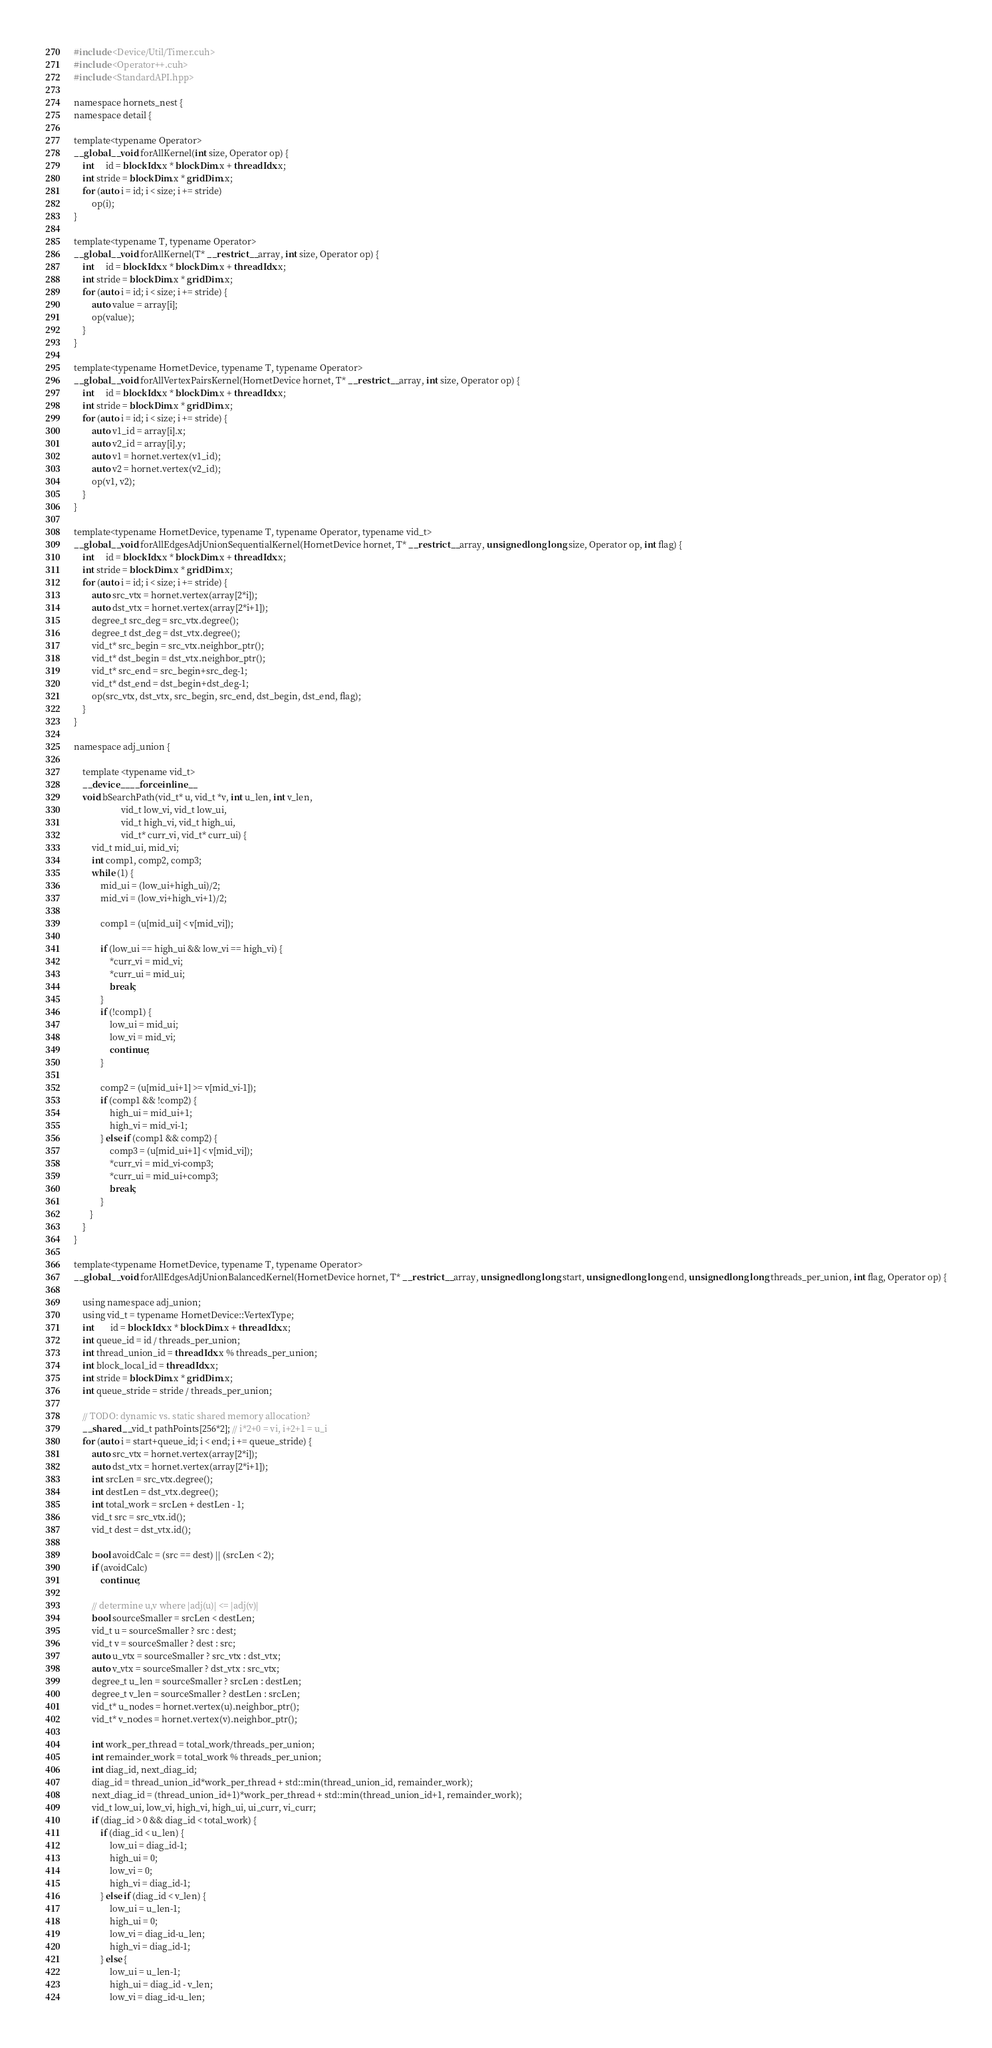Convert code to text. <code><loc_0><loc_0><loc_500><loc_500><_Cuda_>#include <Device/Util/Timer.cuh>
#include <Operator++.cuh>
#include <StandardAPI.hpp>

namespace hornets_nest {
namespace detail {

template<typename Operator>
__global__ void forAllKernel(int size, Operator op) {
    int     id = blockIdx.x * blockDim.x + threadIdx.x;
    int stride = blockDim.x * gridDim.x;
    for (auto i = id; i < size; i += stride)
        op(i);
}

template<typename T, typename Operator>
__global__ void forAllKernel(T* __restrict__ array, int size, Operator op) {
    int     id = blockIdx.x * blockDim.x + threadIdx.x;
    int stride = blockDim.x * gridDim.x;
    for (auto i = id; i < size; i += stride) {
        auto value = array[i];
        op(value);
    }
}

template<typename HornetDevice, typename T, typename Operator>
__global__ void forAllVertexPairsKernel(HornetDevice hornet, T* __restrict__ array, int size, Operator op) {
    int     id = blockIdx.x * blockDim.x + threadIdx.x;
    int stride = blockDim.x * gridDim.x;
    for (auto i = id; i < size; i += stride) {
        auto v1_id = array[i].x;
        auto v2_id = array[i].y;
        auto v1 = hornet.vertex(v1_id);
        auto v2 = hornet.vertex(v2_id);
        op(v1, v2);
    }
}

template<typename HornetDevice, typename T, typename Operator, typename vid_t>
__global__ void forAllEdgesAdjUnionSequentialKernel(HornetDevice hornet, T* __restrict__ array, unsigned long long size, Operator op, int flag) {
    int     id = blockIdx.x * blockDim.x + threadIdx.x;
    int stride = blockDim.x * gridDim.x;
    for (auto i = id; i < size; i += stride) {
        auto src_vtx = hornet.vertex(array[2*i]);
        auto dst_vtx = hornet.vertex(array[2*i+1]);
        degree_t src_deg = src_vtx.degree();
        degree_t dst_deg = dst_vtx.degree();
        vid_t* src_begin = src_vtx.neighbor_ptr();
        vid_t* dst_begin = dst_vtx.neighbor_ptr();
        vid_t* src_end = src_begin+src_deg-1;
        vid_t* dst_end = dst_begin+dst_deg-1;
        op(src_vtx, dst_vtx, src_begin, src_end, dst_begin, dst_end, flag);
    }
}

namespace adj_union {
    
    template <typename vid_t>
    __device__ __forceinline__
    void bSearchPath(vid_t* u, vid_t *v, int u_len, int v_len, 
                     vid_t low_vi, vid_t low_ui, 
                     vid_t high_vi, vid_t high_ui, 
                     vid_t* curr_vi, vid_t* curr_ui) {
        vid_t mid_ui, mid_vi;
        int comp1, comp2, comp3;
        while (1) {
            mid_ui = (low_ui+high_ui)/2;
            mid_vi = (low_vi+high_vi+1)/2;

            comp1 = (u[mid_ui] < v[mid_vi]);
            
            if (low_ui == high_ui && low_vi == high_vi) {
                *curr_vi = mid_vi;
                *curr_ui = mid_ui;
                break;
            }
            if (!comp1) {
                low_ui = mid_ui;
                low_vi = mid_vi;
                continue;
            }

            comp2 = (u[mid_ui+1] >= v[mid_vi-1]);
            if (comp1 && !comp2) {
                high_ui = mid_ui+1;
                high_vi = mid_vi-1;
            } else if (comp1 && comp2) {
                comp3 = (u[mid_ui+1] < v[mid_vi]);
                *curr_vi = mid_vi-comp3;
                *curr_ui = mid_ui+comp3;
                break;
            }
       }
    }
}

template<typename HornetDevice, typename T, typename Operator>
__global__ void forAllEdgesAdjUnionBalancedKernel(HornetDevice hornet, T* __restrict__ array, unsigned long long start, unsigned long long end, unsigned long long threads_per_union, int flag, Operator op) {

    using namespace adj_union;
    using vid_t = typename HornetDevice::VertexType;
    int       id = blockIdx.x * blockDim.x + threadIdx.x;
    int queue_id = id / threads_per_union;
    int thread_union_id = threadIdx.x % threads_per_union;
    int block_local_id = threadIdx.x;
    int stride = blockDim.x * gridDim.x;
    int queue_stride = stride / threads_per_union;

    // TODO: dynamic vs. static shared memory allocation?
    __shared__ vid_t pathPoints[256*2]; // i*2+0 = vi, i+2+1 = u_i
    for (auto i = start+queue_id; i < end; i += queue_stride) {
        auto src_vtx = hornet.vertex(array[2*i]);
        auto dst_vtx = hornet.vertex(array[2*i+1]);
        int srcLen = src_vtx.degree();
        int destLen = dst_vtx.degree();
        int total_work = srcLen + destLen - 1;
        vid_t src = src_vtx.id();
        vid_t dest = dst_vtx.id();

        bool avoidCalc = (src == dest) || (srcLen < 2);
        if (avoidCalc)
            continue;

        // determine u,v where |adj(u)| <= |adj(v)|
        bool sourceSmaller = srcLen < destLen;
        vid_t u = sourceSmaller ? src : dest;
        vid_t v = sourceSmaller ? dest : src;
        auto u_vtx = sourceSmaller ? src_vtx : dst_vtx;
        auto v_vtx = sourceSmaller ? dst_vtx : src_vtx;
        degree_t u_len = sourceSmaller ? srcLen : destLen;
        degree_t v_len = sourceSmaller ? destLen : srcLen;
        vid_t* u_nodes = hornet.vertex(u).neighbor_ptr();
        vid_t* v_nodes = hornet.vertex(v).neighbor_ptr();

        int work_per_thread = total_work/threads_per_union;
        int remainder_work = total_work % threads_per_union;
        int diag_id, next_diag_id;
        diag_id = thread_union_id*work_per_thread + std::min(thread_union_id, remainder_work);
        next_diag_id = (thread_union_id+1)*work_per_thread + std::min(thread_union_id+1, remainder_work);
        vid_t low_ui, low_vi, high_vi, high_ui, ui_curr, vi_curr;
        if (diag_id > 0 && diag_id < total_work) {
            if (diag_id < u_len) {
                low_ui = diag_id-1;
                high_ui = 0;
                low_vi = 0;
                high_vi = diag_id-1;
            } else if (diag_id < v_len) {
                low_ui = u_len-1;
                high_ui = 0;
                low_vi = diag_id-u_len;
                high_vi = diag_id-1;
            } else {
                low_ui = u_len-1;
                high_ui = diag_id - v_len;
                low_vi = diag_id-u_len;</code> 